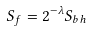<formula> <loc_0><loc_0><loc_500><loc_500>S _ { f } = 2 ^ { - \lambda } S _ { b h }</formula> 